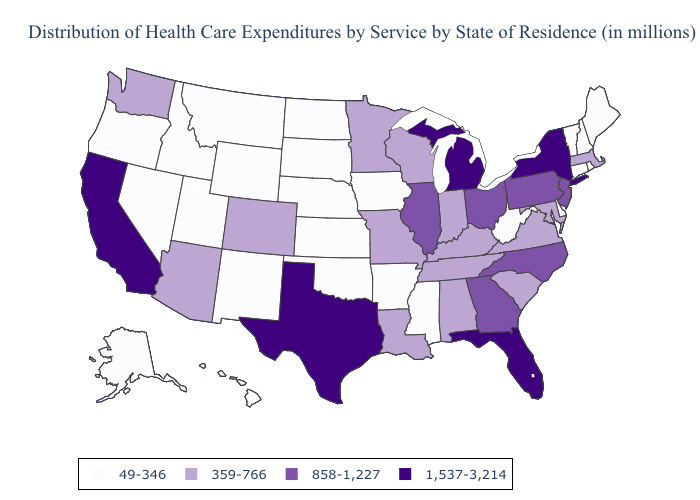What is the highest value in the USA?
Write a very short answer. 1,537-3,214. Name the states that have a value in the range 49-346?
Answer briefly. Alaska, Arkansas, Connecticut, Delaware, Hawaii, Idaho, Iowa, Kansas, Maine, Mississippi, Montana, Nebraska, Nevada, New Hampshire, New Mexico, North Dakota, Oklahoma, Oregon, Rhode Island, South Dakota, Utah, Vermont, West Virginia, Wyoming. Which states have the lowest value in the USA?
Be succinct. Alaska, Arkansas, Connecticut, Delaware, Hawaii, Idaho, Iowa, Kansas, Maine, Mississippi, Montana, Nebraska, Nevada, New Hampshire, New Mexico, North Dakota, Oklahoma, Oregon, Rhode Island, South Dakota, Utah, Vermont, West Virginia, Wyoming. What is the lowest value in the West?
Short answer required. 49-346. Does South Carolina have the lowest value in the USA?
Answer briefly. No. How many symbols are there in the legend?
Keep it brief. 4. What is the value of Mississippi?
Quick response, please. 49-346. Does Virginia have the same value as Colorado?
Be succinct. Yes. Name the states that have a value in the range 49-346?
Answer briefly. Alaska, Arkansas, Connecticut, Delaware, Hawaii, Idaho, Iowa, Kansas, Maine, Mississippi, Montana, Nebraska, Nevada, New Hampshire, New Mexico, North Dakota, Oklahoma, Oregon, Rhode Island, South Dakota, Utah, Vermont, West Virginia, Wyoming. How many symbols are there in the legend?
Answer briefly. 4. Does South Carolina have the same value as Missouri?
Short answer required. Yes. What is the highest value in states that border Massachusetts?
Keep it brief. 1,537-3,214. What is the value of Tennessee?
Quick response, please. 359-766. Name the states that have a value in the range 858-1,227?
Be succinct. Georgia, Illinois, New Jersey, North Carolina, Ohio, Pennsylvania. What is the lowest value in the South?
Short answer required. 49-346. 